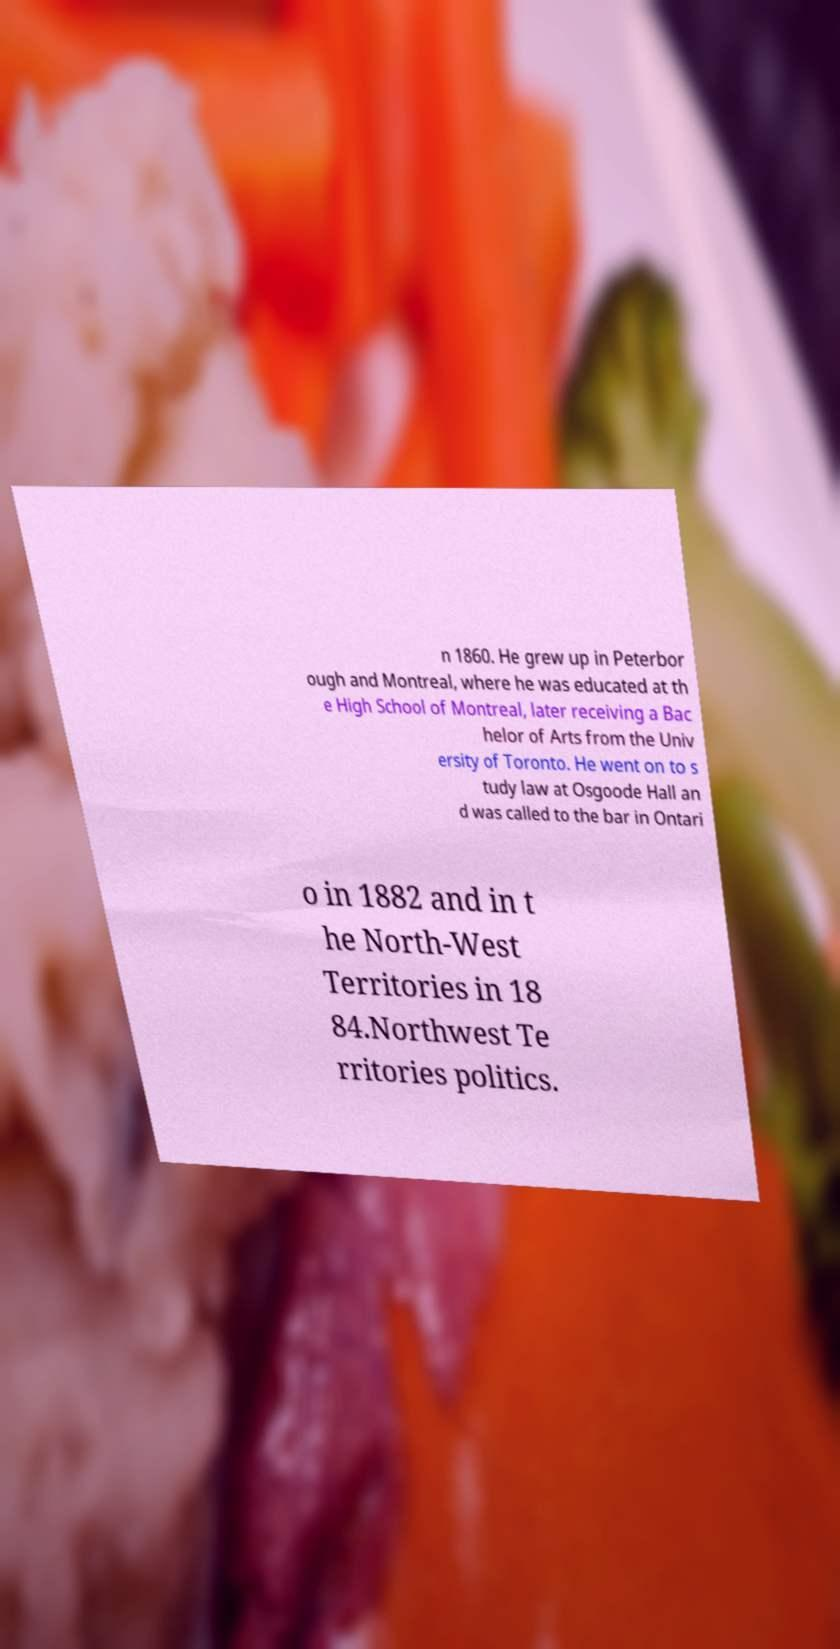Can you accurately transcribe the text from the provided image for me? n 1860. He grew up in Peterbor ough and Montreal, where he was educated at th e High School of Montreal, later receiving a Bac helor of Arts from the Univ ersity of Toronto. He went on to s tudy law at Osgoode Hall an d was called to the bar in Ontari o in 1882 and in t he North-West Territories in 18 84.Northwest Te rritories politics. 